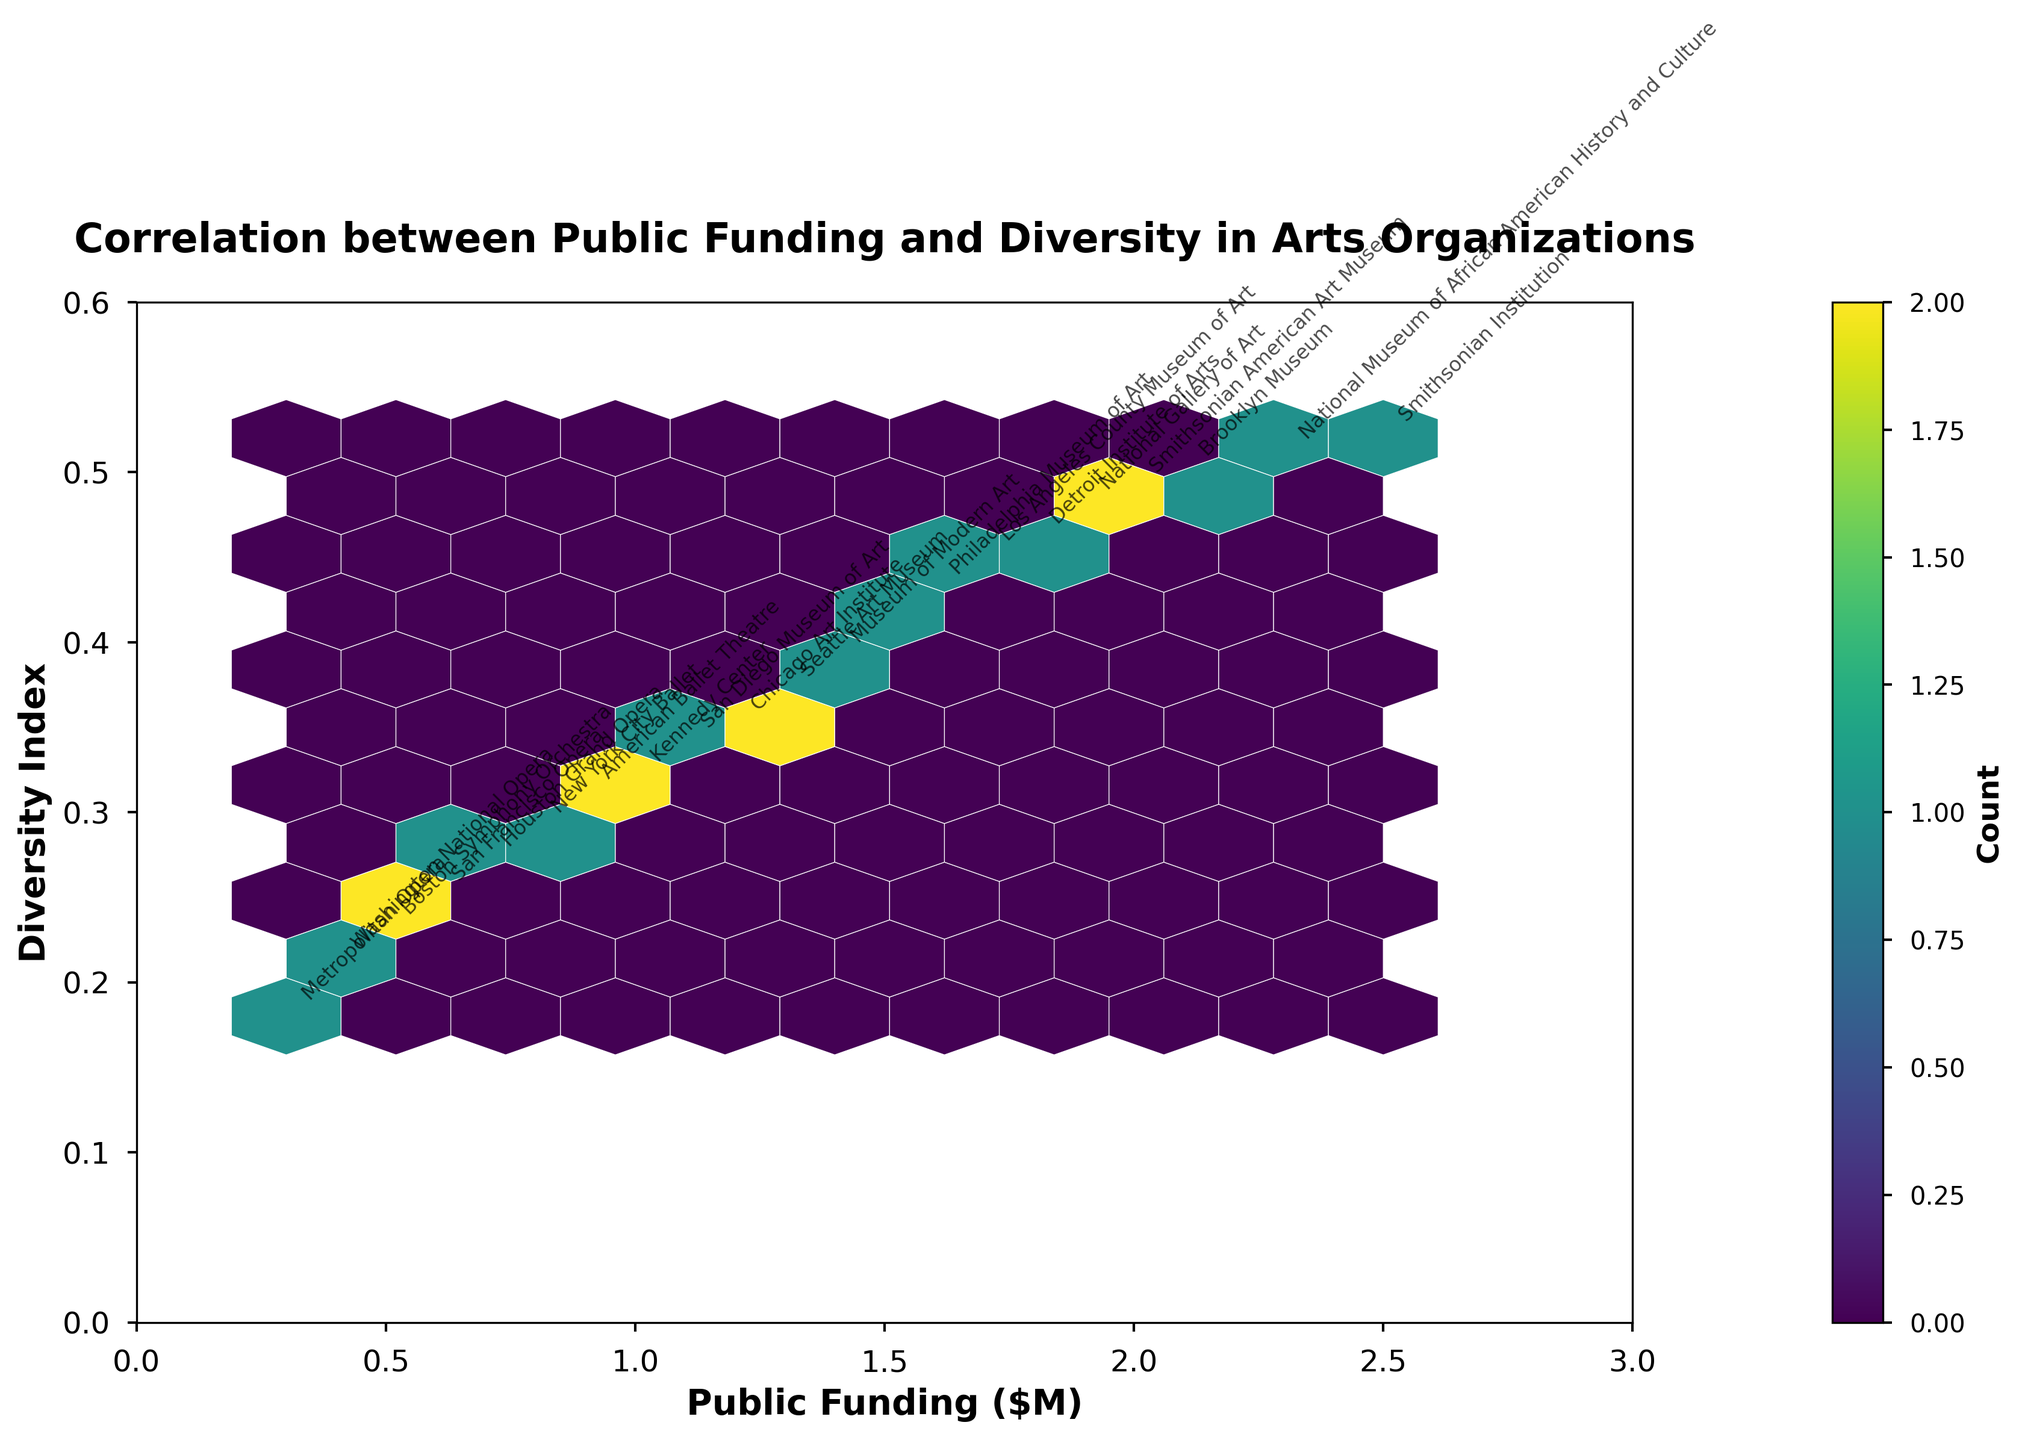What is the title of the plot? The title is generally found at the top of the plot, displaying what the plot represents. In this case, it should be bold and centered.
Answer: Correlation between Public Funding and Diversity in Arts Organizations What are the labels for the x and y axes? The x and y axis labels indicate what is being measured on each axis. In this plot, it should show the variables being compared.
Answer: Public Funding ($M) and Diversity Index How many organizations received more than $2 million in public funding? Look at the x-axis and count the data points that have values greater than 2 million.
Answer: 5 What is the approximate Diversity Index for an organization with $0.5 million in public funding? Find the point on the plot where the x-value is 0.5 and read the corresponding y-value.
Answer: 0.23 Which organization has the highest Diversity Index? Identify the data point with the highest y-value and then read the annotation for the organization.
Answer: Smithsonian Institution How is the hexbin plot color-coded? Examine the color gradient in the hexbin plot and refer to the color bar to determine what the colors represent.
Answer: Count of data points Is there a noticeable trend between public funding and diversity? Examine the overall pattern of data points in the plot to determine if there is an upward, downward, or no clear trend.
Answer: Yes, there seems to be an upward trend Which organization, receiving about $1.8 million in funding, has a Diversity Index lower than 0.5? Find the data points around the x-value of 1.8 and check their y-values, then identify the corresponding annotation.
Answer: Detroit Institute of Arts On average, which organizations, those receiving more than or less than $1 million in public funding, have higher diversity indexes? Compare the y-values (Diversity Index) for organizations grouped by receiving more or less than $1 million in public funding.
Answer: More than $1 million Do any organizations have both the smallest public funding and the lowest Diversity Index? Identify the data points with the minimum x-value and minimum y-value and check if they correspond to the same organization.
Answer: No 